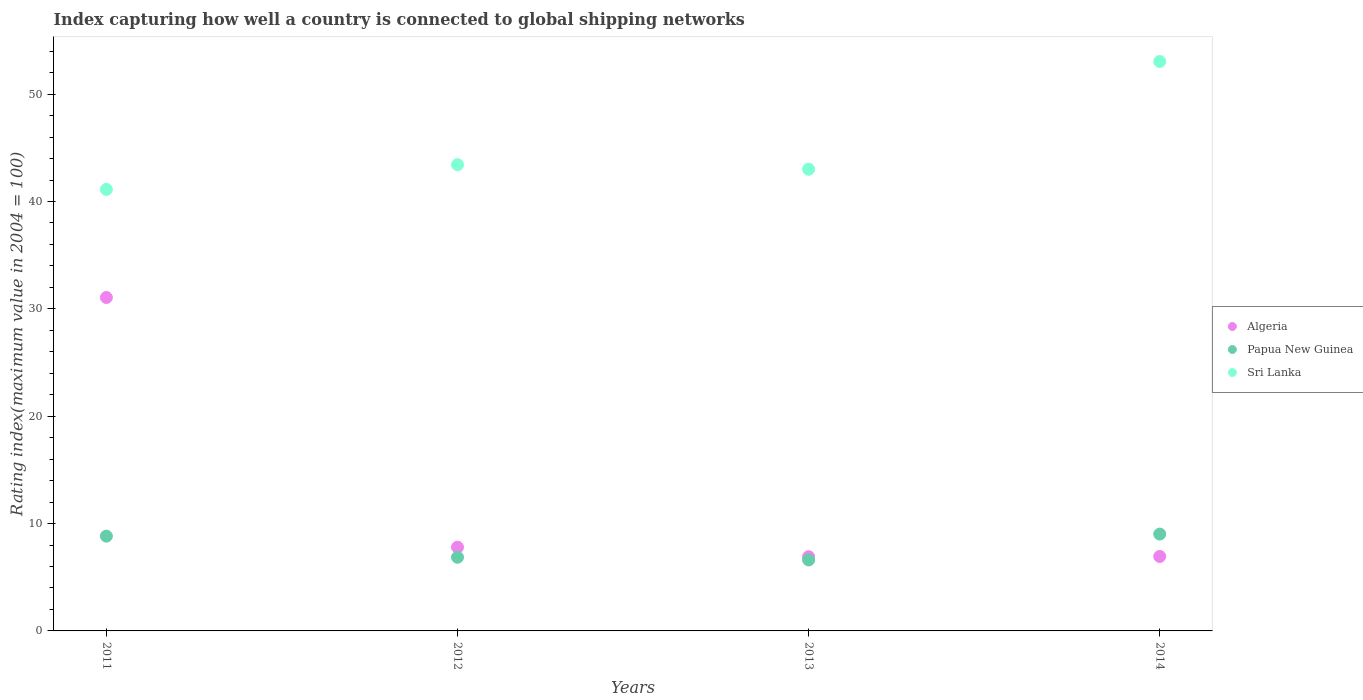How many different coloured dotlines are there?
Offer a very short reply. 3. What is the rating index in Papua New Guinea in 2014?
Your response must be concise. 9.02. Across all years, what is the maximum rating index in Sri Lanka?
Your response must be concise. 53.04. Across all years, what is the minimum rating index in Algeria?
Your answer should be very brief. 6.91. What is the total rating index in Algeria in the graph?
Your answer should be compact. 52.71. What is the difference between the rating index in Papua New Guinea in 2013 and that in 2014?
Provide a succinct answer. -2.41. What is the difference between the rating index in Papua New Guinea in 2013 and the rating index in Sri Lanka in 2012?
Offer a very short reply. -36.82. What is the average rating index in Algeria per year?
Your answer should be compact. 13.18. In the year 2014, what is the difference between the rating index in Algeria and rating index in Sri Lanka?
Your response must be concise. -46.11. In how many years, is the rating index in Papua New Guinea greater than 26?
Make the answer very short. 0. What is the ratio of the rating index in Papua New Guinea in 2012 to that in 2014?
Provide a short and direct response. 0.76. Is the rating index in Papua New Guinea in 2013 less than that in 2014?
Provide a succinct answer. Yes. What is the difference between the highest and the second highest rating index in Sri Lanka?
Keep it short and to the point. 9.61. What is the difference between the highest and the lowest rating index in Algeria?
Keep it short and to the point. 24.15. In how many years, is the rating index in Papua New Guinea greater than the average rating index in Papua New Guinea taken over all years?
Your answer should be compact. 2. Is the sum of the rating index in Sri Lanka in 2011 and 2012 greater than the maximum rating index in Papua New Guinea across all years?
Offer a very short reply. Yes. Is the rating index in Algeria strictly less than the rating index in Sri Lanka over the years?
Your response must be concise. Yes. How many dotlines are there?
Your response must be concise. 3. Does the graph contain any zero values?
Ensure brevity in your answer.  No. Does the graph contain grids?
Provide a succinct answer. No. Where does the legend appear in the graph?
Your response must be concise. Center right. How are the legend labels stacked?
Offer a terse response. Vertical. What is the title of the graph?
Make the answer very short. Index capturing how well a country is connected to global shipping networks. Does "Albania" appear as one of the legend labels in the graph?
Your answer should be compact. No. What is the label or title of the X-axis?
Your answer should be very brief. Years. What is the label or title of the Y-axis?
Ensure brevity in your answer.  Rating index(maximum value in 2004 = 100). What is the Rating index(maximum value in 2004 = 100) of Algeria in 2011?
Ensure brevity in your answer.  31.06. What is the Rating index(maximum value in 2004 = 100) in Papua New Guinea in 2011?
Give a very brief answer. 8.83. What is the Rating index(maximum value in 2004 = 100) of Sri Lanka in 2011?
Your response must be concise. 41.13. What is the Rating index(maximum value in 2004 = 100) of Algeria in 2012?
Your response must be concise. 7.8. What is the Rating index(maximum value in 2004 = 100) of Papua New Guinea in 2012?
Keep it short and to the point. 6.86. What is the Rating index(maximum value in 2004 = 100) of Sri Lanka in 2012?
Offer a terse response. 43.43. What is the Rating index(maximum value in 2004 = 100) of Algeria in 2013?
Offer a very short reply. 6.91. What is the Rating index(maximum value in 2004 = 100) of Papua New Guinea in 2013?
Keep it short and to the point. 6.61. What is the Rating index(maximum value in 2004 = 100) of Sri Lanka in 2013?
Provide a succinct answer. 43.01. What is the Rating index(maximum value in 2004 = 100) of Algeria in 2014?
Your answer should be very brief. 6.94. What is the Rating index(maximum value in 2004 = 100) of Papua New Guinea in 2014?
Your answer should be compact. 9.02. What is the Rating index(maximum value in 2004 = 100) of Sri Lanka in 2014?
Provide a short and direct response. 53.04. Across all years, what is the maximum Rating index(maximum value in 2004 = 100) in Algeria?
Your answer should be very brief. 31.06. Across all years, what is the maximum Rating index(maximum value in 2004 = 100) in Papua New Guinea?
Your answer should be compact. 9.02. Across all years, what is the maximum Rating index(maximum value in 2004 = 100) of Sri Lanka?
Offer a terse response. 53.04. Across all years, what is the minimum Rating index(maximum value in 2004 = 100) in Algeria?
Offer a very short reply. 6.91. Across all years, what is the minimum Rating index(maximum value in 2004 = 100) in Papua New Guinea?
Make the answer very short. 6.61. Across all years, what is the minimum Rating index(maximum value in 2004 = 100) in Sri Lanka?
Provide a short and direct response. 41.13. What is the total Rating index(maximum value in 2004 = 100) of Algeria in the graph?
Offer a very short reply. 52.71. What is the total Rating index(maximum value in 2004 = 100) of Papua New Guinea in the graph?
Ensure brevity in your answer.  31.32. What is the total Rating index(maximum value in 2004 = 100) of Sri Lanka in the graph?
Your answer should be very brief. 180.61. What is the difference between the Rating index(maximum value in 2004 = 100) of Algeria in 2011 and that in 2012?
Offer a very short reply. 23.26. What is the difference between the Rating index(maximum value in 2004 = 100) in Papua New Guinea in 2011 and that in 2012?
Ensure brevity in your answer.  1.97. What is the difference between the Rating index(maximum value in 2004 = 100) in Sri Lanka in 2011 and that in 2012?
Your answer should be very brief. -2.3. What is the difference between the Rating index(maximum value in 2004 = 100) in Algeria in 2011 and that in 2013?
Make the answer very short. 24.15. What is the difference between the Rating index(maximum value in 2004 = 100) in Papua New Guinea in 2011 and that in 2013?
Provide a succinct answer. 2.22. What is the difference between the Rating index(maximum value in 2004 = 100) in Sri Lanka in 2011 and that in 2013?
Provide a short and direct response. -1.88. What is the difference between the Rating index(maximum value in 2004 = 100) in Algeria in 2011 and that in 2014?
Your answer should be compact. 24.12. What is the difference between the Rating index(maximum value in 2004 = 100) of Papua New Guinea in 2011 and that in 2014?
Your answer should be very brief. -0.19. What is the difference between the Rating index(maximum value in 2004 = 100) of Sri Lanka in 2011 and that in 2014?
Offer a terse response. -11.91. What is the difference between the Rating index(maximum value in 2004 = 100) in Algeria in 2012 and that in 2013?
Provide a succinct answer. 0.89. What is the difference between the Rating index(maximum value in 2004 = 100) in Sri Lanka in 2012 and that in 2013?
Your answer should be very brief. 0.42. What is the difference between the Rating index(maximum value in 2004 = 100) of Algeria in 2012 and that in 2014?
Give a very brief answer. 0.86. What is the difference between the Rating index(maximum value in 2004 = 100) in Papua New Guinea in 2012 and that in 2014?
Offer a terse response. -2.16. What is the difference between the Rating index(maximum value in 2004 = 100) in Sri Lanka in 2012 and that in 2014?
Make the answer very short. -9.61. What is the difference between the Rating index(maximum value in 2004 = 100) of Algeria in 2013 and that in 2014?
Give a very brief answer. -0.03. What is the difference between the Rating index(maximum value in 2004 = 100) in Papua New Guinea in 2013 and that in 2014?
Offer a very short reply. -2.41. What is the difference between the Rating index(maximum value in 2004 = 100) of Sri Lanka in 2013 and that in 2014?
Give a very brief answer. -10.03. What is the difference between the Rating index(maximum value in 2004 = 100) in Algeria in 2011 and the Rating index(maximum value in 2004 = 100) in Papua New Guinea in 2012?
Keep it short and to the point. 24.2. What is the difference between the Rating index(maximum value in 2004 = 100) of Algeria in 2011 and the Rating index(maximum value in 2004 = 100) of Sri Lanka in 2012?
Give a very brief answer. -12.37. What is the difference between the Rating index(maximum value in 2004 = 100) in Papua New Guinea in 2011 and the Rating index(maximum value in 2004 = 100) in Sri Lanka in 2012?
Offer a terse response. -34.6. What is the difference between the Rating index(maximum value in 2004 = 100) in Algeria in 2011 and the Rating index(maximum value in 2004 = 100) in Papua New Guinea in 2013?
Provide a short and direct response. 24.45. What is the difference between the Rating index(maximum value in 2004 = 100) of Algeria in 2011 and the Rating index(maximum value in 2004 = 100) of Sri Lanka in 2013?
Make the answer very short. -11.95. What is the difference between the Rating index(maximum value in 2004 = 100) in Papua New Guinea in 2011 and the Rating index(maximum value in 2004 = 100) in Sri Lanka in 2013?
Your answer should be compact. -34.18. What is the difference between the Rating index(maximum value in 2004 = 100) of Algeria in 2011 and the Rating index(maximum value in 2004 = 100) of Papua New Guinea in 2014?
Offer a very short reply. 22.04. What is the difference between the Rating index(maximum value in 2004 = 100) in Algeria in 2011 and the Rating index(maximum value in 2004 = 100) in Sri Lanka in 2014?
Provide a short and direct response. -21.98. What is the difference between the Rating index(maximum value in 2004 = 100) in Papua New Guinea in 2011 and the Rating index(maximum value in 2004 = 100) in Sri Lanka in 2014?
Offer a terse response. -44.21. What is the difference between the Rating index(maximum value in 2004 = 100) of Algeria in 2012 and the Rating index(maximum value in 2004 = 100) of Papua New Guinea in 2013?
Your answer should be compact. 1.19. What is the difference between the Rating index(maximum value in 2004 = 100) of Algeria in 2012 and the Rating index(maximum value in 2004 = 100) of Sri Lanka in 2013?
Keep it short and to the point. -35.21. What is the difference between the Rating index(maximum value in 2004 = 100) of Papua New Guinea in 2012 and the Rating index(maximum value in 2004 = 100) of Sri Lanka in 2013?
Offer a terse response. -36.15. What is the difference between the Rating index(maximum value in 2004 = 100) of Algeria in 2012 and the Rating index(maximum value in 2004 = 100) of Papua New Guinea in 2014?
Provide a succinct answer. -1.22. What is the difference between the Rating index(maximum value in 2004 = 100) of Algeria in 2012 and the Rating index(maximum value in 2004 = 100) of Sri Lanka in 2014?
Ensure brevity in your answer.  -45.24. What is the difference between the Rating index(maximum value in 2004 = 100) of Papua New Guinea in 2012 and the Rating index(maximum value in 2004 = 100) of Sri Lanka in 2014?
Keep it short and to the point. -46.18. What is the difference between the Rating index(maximum value in 2004 = 100) of Algeria in 2013 and the Rating index(maximum value in 2004 = 100) of Papua New Guinea in 2014?
Your answer should be very brief. -2.11. What is the difference between the Rating index(maximum value in 2004 = 100) in Algeria in 2013 and the Rating index(maximum value in 2004 = 100) in Sri Lanka in 2014?
Keep it short and to the point. -46.13. What is the difference between the Rating index(maximum value in 2004 = 100) of Papua New Guinea in 2013 and the Rating index(maximum value in 2004 = 100) of Sri Lanka in 2014?
Make the answer very short. -46.43. What is the average Rating index(maximum value in 2004 = 100) of Algeria per year?
Your answer should be very brief. 13.18. What is the average Rating index(maximum value in 2004 = 100) of Papua New Guinea per year?
Ensure brevity in your answer.  7.83. What is the average Rating index(maximum value in 2004 = 100) of Sri Lanka per year?
Offer a terse response. 45.15. In the year 2011, what is the difference between the Rating index(maximum value in 2004 = 100) in Algeria and Rating index(maximum value in 2004 = 100) in Papua New Guinea?
Offer a terse response. 22.23. In the year 2011, what is the difference between the Rating index(maximum value in 2004 = 100) in Algeria and Rating index(maximum value in 2004 = 100) in Sri Lanka?
Give a very brief answer. -10.07. In the year 2011, what is the difference between the Rating index(maximum value in 2004 = 100) of Papua New Guinea and Rating index(maximum value in 2004 = 100) of Sri Lanka?
Offer a terse response. -32.3. In the year 2012, what is the difference between the Rating index(maximum value in 2004 = 100) of Algeria and Rating index(maximum value in 2004 = 100) of Sri Lanka?
Provide a short and direct response. -35.63. In the year 2012, what is the difference between the Rating index(maximum value in 2004 = 100) in Papua New Guinea and Rating index(maximum value in 2004 = 100) in Sri Lanka?
Provide a succinct answer. -36.57. In the year 2013, what is the difference between the Rating index(maximum value in 2004 = 100) in Algeria and Rating index(maximum value in 2004 = 100) in Papua New Guinea?
Your answer should be very brief. 0.3. In the year 2013, what is the difference between the Rating index(maximum value in 2004 = 100) of Algeria and Rating index(maximum value in 2004 = 100) of Sri Lanka?
Offer a very short reply. -36.1. In the year 2013, what is the difference between the Rating index(maximum value in 2004 = 100) in Papua New Guinea and Rating index(maximum value in 2004 = 100) in Sri Lanka?
Give a very brief answer. -36.4. In the year 2014, what is the difference between the Rating index(maximum value in 2004 = 100) of Algeria and Rating index(maximum value in 2004 = 100) of Papua New Guinea?
Provide a succinct answer. -2.08. In the year 2014, what is the difference between the Rating index(maximum value in 2004 = 100) of Algeria and Rating index(maximum value in 2004 = 100) of Sri Lanka?
Make the answer very short. -46.11. In the year 2014, what is the difference between the Rating index(maximum value in 2004 = 100) in Papua New Guinea and Rating index(maximum value in 2004 = 100) in Sri Lanka?
Your response must be concise. -44.02. What is the ratio of the Rating index(maximum value in 2004 = 100) in Algeria in 2011 to that in 2012?
Offer a terse response. 3.98. What is the ratio of the Rating index(maximum value in 2004 = 100) of Papua New Guinea in 2011 to that in 2012?
Provide a succinct answer. 1.29. What is the ratio of the Rating index(maximum value in 2004 = 100) in Sri Lanka in 2011 to that in 2012?
Offer a very short reply. 0.95. What is the ratio of the Rating index(maximum value in 2004 = 100) of Algeria in 2011 to that in 2013?
Ensure brevity in your answer.  4.49. What is the ratio of the Rating index(maximum value in 2004 = 100) in Papua New Guinea in 2011 to that in 2013?
Your response must be concise. 1.34. What is the ratio of the Rating index(maximum value in 2004 = 100) in Sri Lanka in 2011 to that in 2013?
Offer a terse response. 0.96. What is the ratio of the Rating index(maximum value in 2004 = 100) of Algeria in 2011 to that in 2014?
Give a very brief answer. 4.48. What is the ratio of the Rating index(maximum value in 2004 = 100) of Papua New Guinea in 2011 to that in 2014?
Your answer should be compact. 0.98. What is the ratio of the Rating index(maximum value in 2004 = 100) in Sri Lanka in 2011 to that in 2014?
Offer a terse response. 0.78. What is the ratio of the Rating index(maximum value in 2004 = 100) of Algeria in 2012 to that in 2013?
Your answer should be very brief. 1.13. What is the ratio of the Rating index(maximum value in 2004 = 100) of Papua New Guinea in 2012 to that in 2013?
Provide a short and direct response. 1.04. What is the ratio of the Rating index(maximum value in 2004 = 100) in Sri Lanka in 2012 to that in 2013?
Ensure brevity in your answer.  1.01. What is the ratio of the Rating index(maximum value in 2004 = 100) in Algeria in 2012 to that in 2014?
Offer a terse response. 1.12. What is the ratio of the Rating index(maximum value in 2004 = 100) in Papua New Guinea in 2012 to that in 2014?
Ensure brevity in your answer.  0.76. What is the ratio of the Rating index(maximum value in 2004 = 100) of Sri Lanka in 2012 to that in 2014?
Give a very brief answer. 0.82. What is the ratio of the Rating index(maximum value in 2004 = 100) in Algeria in 2013 to that in 2014?
Ensure brevity in your answer.  1. What is the ratio of the Rating index(maximum value in 2004 = 100) of Papua New Guinea in 2013 to that in 2014?
Give a very brief answer. 0.73. What is the ratio of the Rating index(maximum value in 2004 = 100) in Sri Lanka in 2013 to that in 2014?
Your answer should be compact. 0.81. What is the difference between the highest and the second highest Rating index(maximum value in 2004 = 100) of Algeria?
Your answer should be compact. 23.26. What is the difference between the highest and the second highest Rating index(maximum value in 2004 = 100) of Papua New Guinea?
Offer a terse response. 0.19. What is the difference between the highest and the second highest Rating index(maximum value in 2004 = 100) of Sri Lanka?
Your response must be concise. 9.61. What is the difference between the highest and the lowest Rating index(maximum value in 2004 = 100) of Algeria?
Offer a very short reply. 24.15. What is the difference between the highest and the lowest Rating index(maximum value in 2004 = 100) of Papua New Guinea?
Offer a very short reply. 2.41. What is the difference between the highest and the lowest Rating index(maximum value in 2004 = 100) of Sri Lanka?
Your answer should be compact. 11.91. 